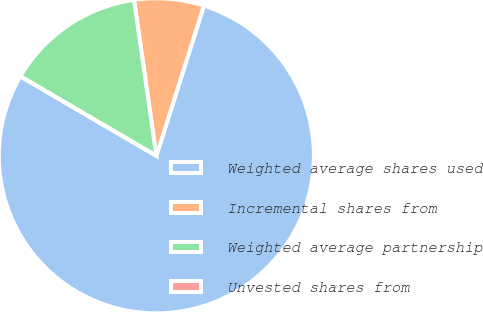Convert chart. <chart><loc_0><loc_0><loc_500><loc_500><pie_chart><fcel>Weighted average shares used<fcel>Incremental shares from<fcel>Weighted average partnership<fcel>Unvested shares from<nl><fcel>78.54%<fcel>7.15%<fcel>14.31%<fcel>0.0%<nl></chart> 